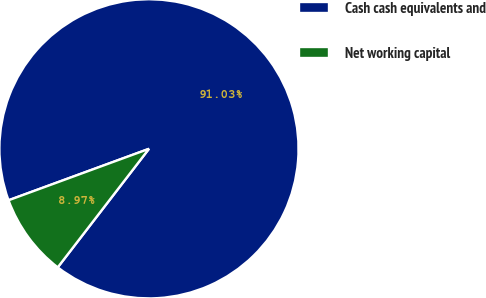Convert chart to OTSL. <chart><loc_0><loc_0><loc_500><loc_500><pie_chart><fcel>Cash cash equivalents and<fcel>Net working capital<nl><fcel>91.03%<fcel>8.97%<nl></chart> 